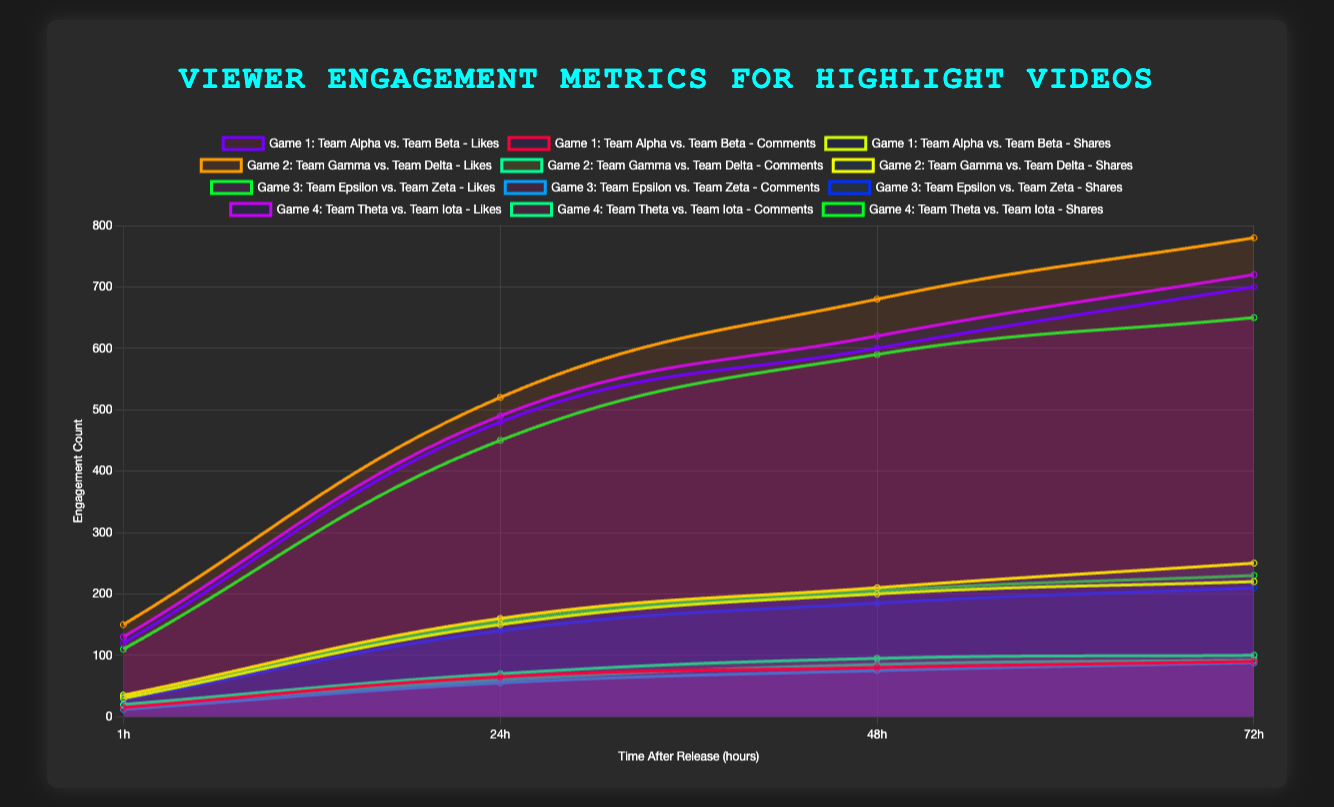Which match's video had the highest number of likes at the 72-hour mark? By examining the likes at the 72-hour mark for all matches, we see that the likes for Game 2: Team Gamma vs. Team Delta are the highest at 780.
Answer: Game 2: Team Gamma vs. Team Delta Which match's video had the lowest increase in comments from the 24-hour mark to the 48-hour mark? Calculate the increase in comments for each match: Game 1 (80-65=15), Game 2 (95-70=25), Game 3 (75-55=20), Game 4 (85-60=25). The lowest increase is for Game 1 at 15.
Answer: Game 1: Team Alpha vs. Team Beta What is the total number of shares for Game 3: Team Epsilon vs. Team Zeta over the entire 72-hour period? Summing the shares for Game 3 at different time points yields: 28 (1 hour) + 140 (24 hours) + 185 (48 hours) + 210 (72 hours) = 563.
Answer: 563 Which match's video saw the highest rate of increase in likes between the 1-hour mark and the 24-hour mark? Calculate the rate of increase for each match by (likes at 24 hours - likes at 1 hour): Game 1 (480-120=360), Game 2 (520-150=370), Game 3 (450-110=340), Game 4 (490-130=360). The highest rate of increase is for Game 2 at 370.
Answer: Game 2: Team Gamma vs. Team Delta Which videos have the same number of comments at the 72-hour mark? At the 72-hour mark, compare the comments for each match: Game 1 (90), Game 2 (100), Game 3 (88), Game 4 (92). None of the videos have the same number of comments.
Answer: None What is the average number of shares for Game 4: Team Theta vs. Team Iota over the first 24 hours? Calculate the average by summing the shares at 1-hour and 24-hour marks, then dividing by 2: (33 + 155) / 2 = 94.
Answer: 94 By how much did the number of likes increase on average per hour for Game 1: Team Alpha vs. Team Beta over the first 72 hours? Calculate the rate by (likes at 72 hours - likes at 1 hour) / 72: (700 - 120) / 72 ≈ 8.06.
Answer: ≈ 8.06 Which match's video experienced the highest increase in shares from the 48-hour mark to the 72-hour mark? Calculate the increase in shares for each match: Game 1 (220-200=20), Game 2 (250-210=40), Game 3 (210-185=25), Game 4 (230-205=25). The highest increase is for Game 2 at 40.
Answer: Game 2: Team Gamma vs. Team Delta 